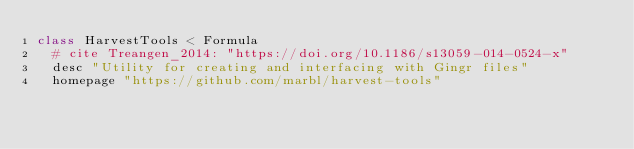Convert code to text. <code><loc_0><loc_0><loc_500><loc_500><_Ruby_>class HarvestTools < Formula
  # cite Treangen_2014: "https://doi.org/10.1186/s13059-014-0524-x"
  desc "Utility for creating and interfacing with Gingr files"
  homepage "https://github.com/marbl/harvest-tools"</code> 